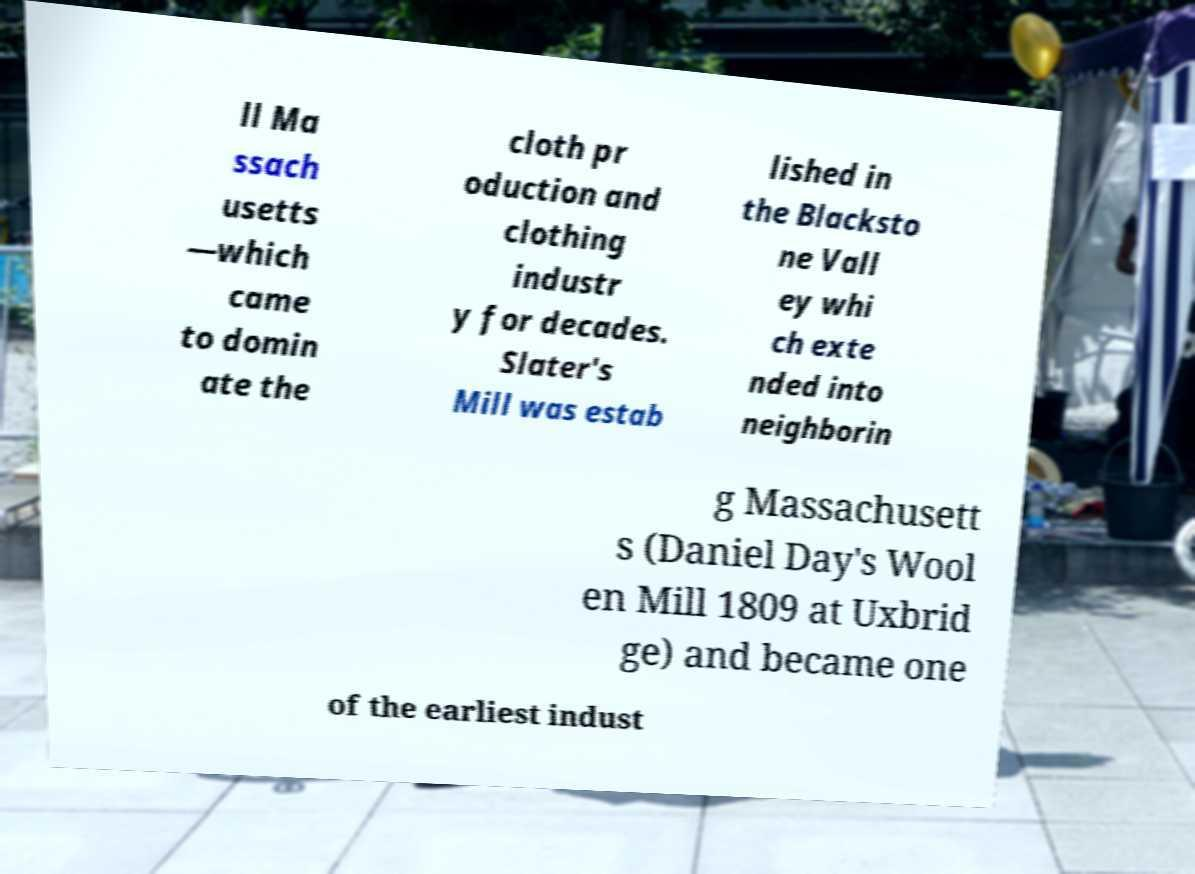Could you assist in decoding the text presented in this image and type it out clearly? ll Ma ssach usetts —which came to domin ate the cloth pr oduction and clothing industr y for decades. Slater's Mill was estab lished in the Blacksto ne Vall ey whi ch exte nded into neighborin g Massachusett s (Daniel Day's Wool en Mill 1809 at Uxbrid ge) and became one of the earliest indust 